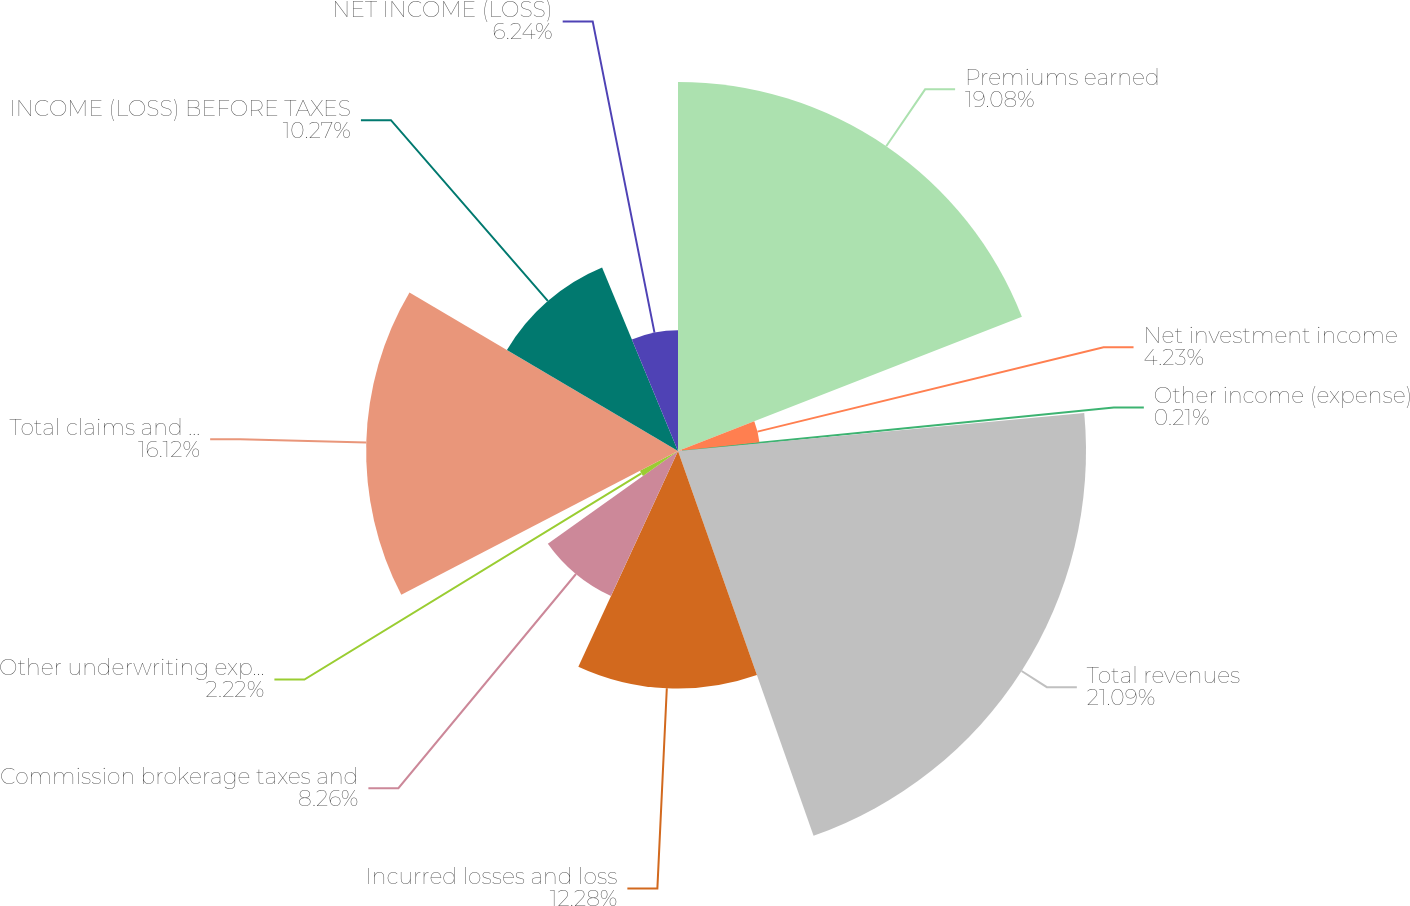<chart> <loc_0><loc_0><loc_500><loc_500><pie_chart><fcel>Premiums earned<fcel>Net investment income<fcel>Other income (expense)<fcel>Total revenues<fcel>Incurred losses and loss<fcel>Commission brokerage taxes and<fcel>Other underwriting expenses<fcel>Total claims and expenses<fcel>INCOME (LOSS) BEFORE TAXES<fcel>NET INCOME (LOSS)<nl><fcel>19.08%<fcel>4.23%<fcel>0.21%<fcel>21.09%<fcel>12.28%<fcel>8.26%<fcel>2.22%<fcel>16.12%<fcel>10.27%<fcel>6.24%<nl></chart> 